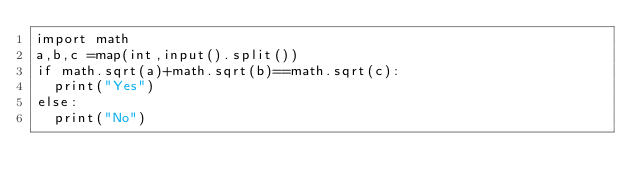Convert code to text. <code><loc_0><loc_0><loc_500><loc_500><_Python_>import math
a,b,c =map(int,input().split())
if math.sqrt(a)+math.sqrt(b)==math.sqrt(c):
  print("Yes")
else:
  print("No")
</code> 